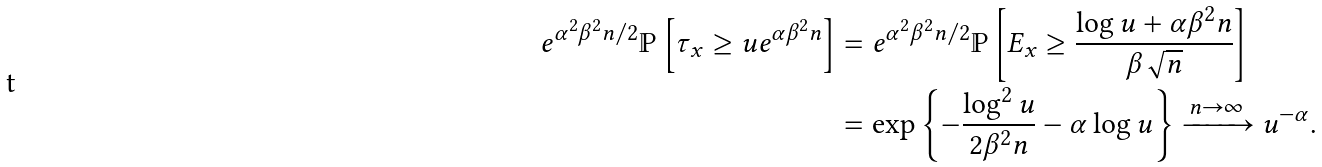<formula> <loc_0><loc_0><loc_500><loc_500>e ^ { \alpha ^ { 2 } \beta ^ { 2 } n / 2 } \mathbb { P } \left [ \tau _ { x } \geq u e ^ { \alpha \beta ^ { 2 } n } \right ] & = e ^ { \alpha ^ { 2 } \beta ^ { 2 } n / 2 } \mathbb { P } \left [ E _ { x } \geq \frac { \log u + \alpha \beta ^ { 2 } n } { \beta \sqrt { n } } \right ] \\ & = \exp \left \{ - \frac { \log ^ { 2 } u } { 2 \beta ^ { 2 } n } - \alpha \log u \right \} \xrightarrow { n \to \infty } u ^ { - \alpha } .</formula> 